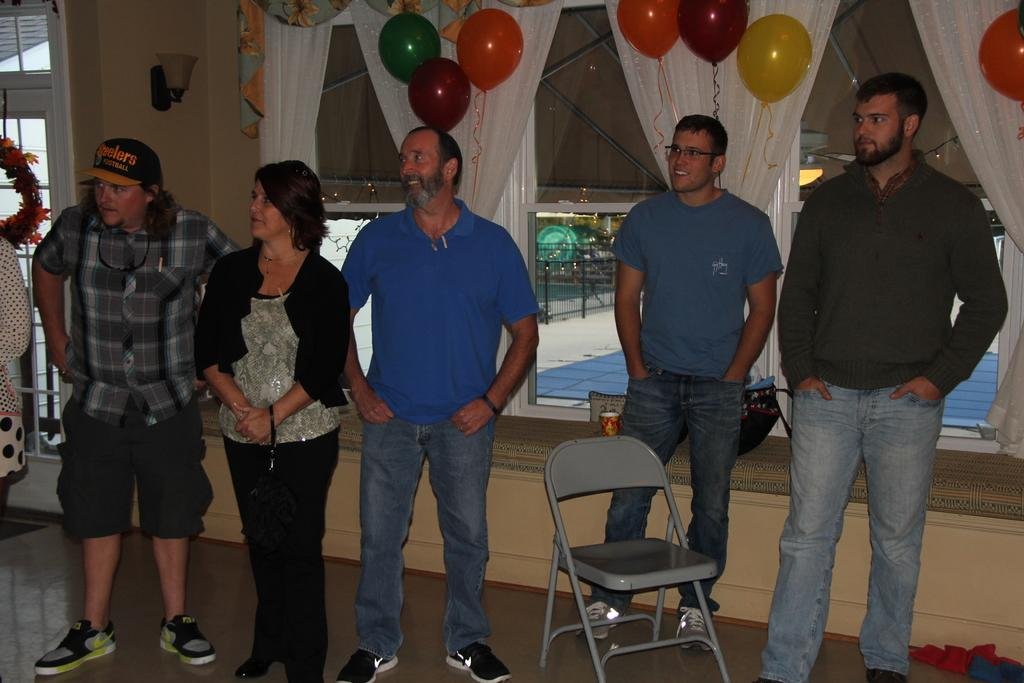What is happening in the middle of the image? There are persons standing in the middle of the image. What can be seen at the top of the image? There is a chair, balloons, and a curtain at the top of the image. What type of meal is being prepared in the image? There is no meal preparation visible in the image. What color is the skin of the persons standing in the middle of the image? The provided facts do not mention the color of the persons' skin, so it cannot be determined from the image. 